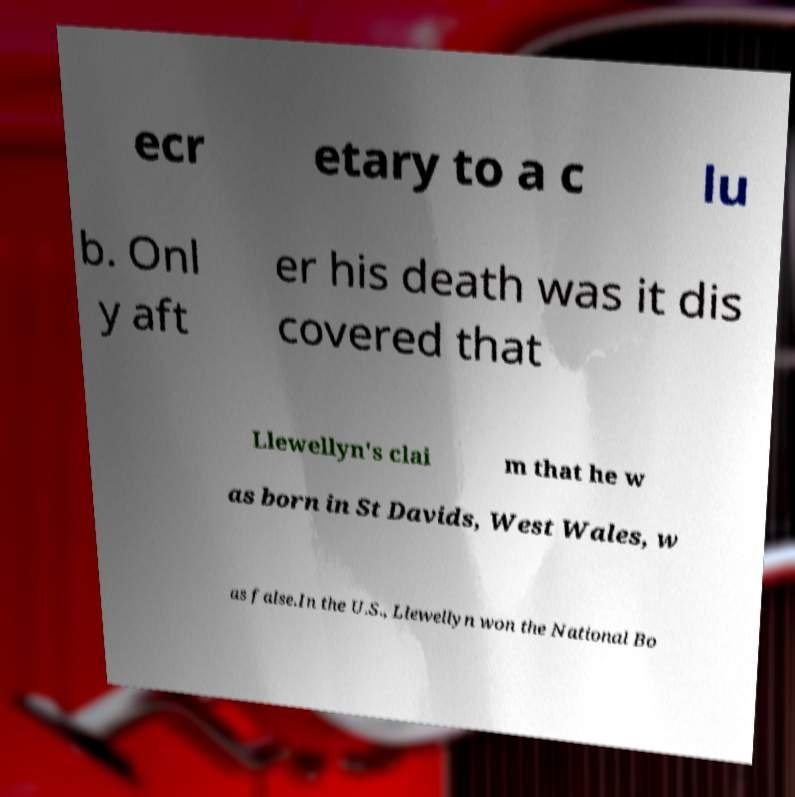Can you accurately transcribe the text from the provided image for me? ecr etary to a c lu b. Onl y aft er his death was it dis covered that Llewellyn's clai m that he w as born in St Davids, West Wales, w as false.In the U.S., Llewellyn won the National Bo 